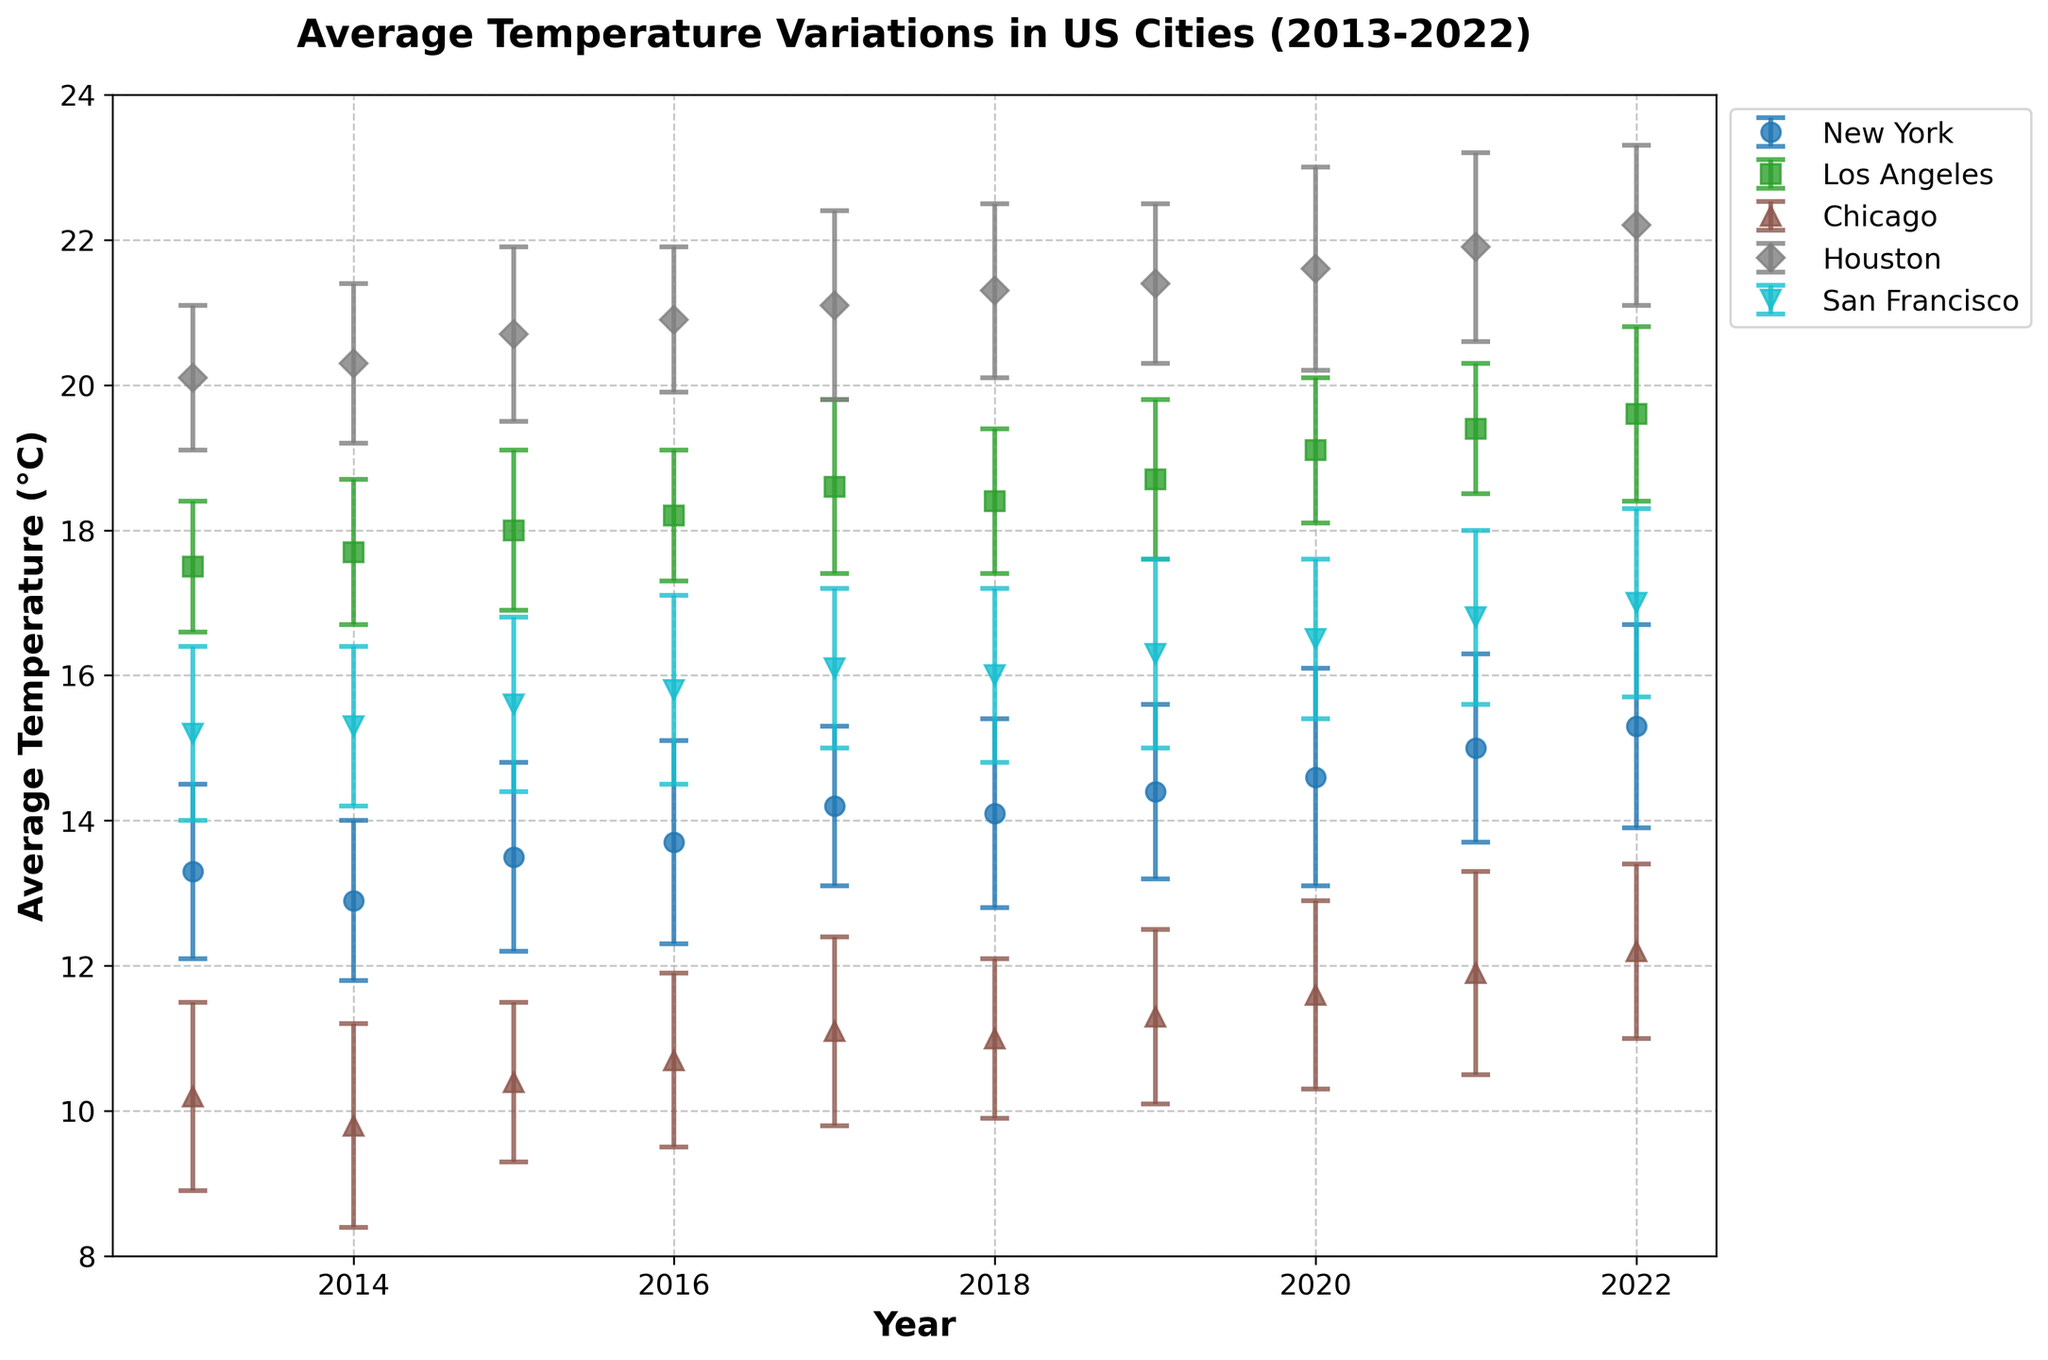What does the title of the plot say? The title is placed at the top of the plot and gives a clear indication of what the data represents. According to the plot, the title is "Average Temperature Variations in US Cities (2013-2022)."
Answer: "Average Temperature Variations in US Cities (2013-2022)" What are the x-axis and y-axis labels? The labels for the x-axis and y-axis are written next to their respective axes. The x-axis label is "Year" and the y-axis label is "Average Temperature (°C)."
Answer: "Year" and "Average Temperature (°C)" Which city had the highest temperature in 2021 according to the plot? To find this, look at the data points for 2021 on the x-axis and compare the y-values for all cities. Los Angeles has the highest temperature for 2021.
Answer: Los Angeles How did the average temperature in New York change from 2013 to 2022? Observe the data points for New York from 2013 to 2022 on the plot. The temperatures in 2013 and 2022 are 13.3°C and 15.3°C respectively, showing an increase of 2 degrees.
Answer: Increased by 2 degrees Which city generally showed the least variation in temperature over the decade? Examine the vertical spread of data points for each city. The city with data points closest together indicates the least variation. Los Angeles has the least variation as its points are the most closely bunched together.
Answer: Los Angeles What is the error bar range for Houston in 2017, and what does this signify? For 2017, find the middle value for Houston and consider the length of the error bars extending above and below this point. Houston’s average temperature in 2017 is 21.1°C with an error margin of 1.3°C, so the range is from 19.8°C to 22.4°C. This means the true average temperature could vary within this range.
Answer: 19.8°C to 22.4°C Compare the temperature trends of Chicago and San Francisco from 2013 to 2022. To compare trends, look at the slope of the data points for Chicago and San Francisco from 2013 to 2022. Both cities show an upward trend, but Chicago starts lower and rises to around 12.2°C while San Francisco starts higher and rises to around 17.0°C.
Answer: Both cities show an upward trend What year did New York have its highest average temperature in the decade, and what was it? Identify the highest data point for New York and locate the corresponding year. New York’s highest average temperature occurred in 2022 with a temperature of 15.3°C.
Answer: 2022, 15.3°C How does the error margin for Los Angeles in 2020 compare to that in 2022? Look at the length of the error bars for Los Angeles in 2020 and 2022. In 2020, the error is 1.0, while in 2022, the error is larger at 1.2. This indicates that the uncertainty in the average temperature was slightly higher in 2022.
Answer: Smaller in 2020 by 0.2 degrees 